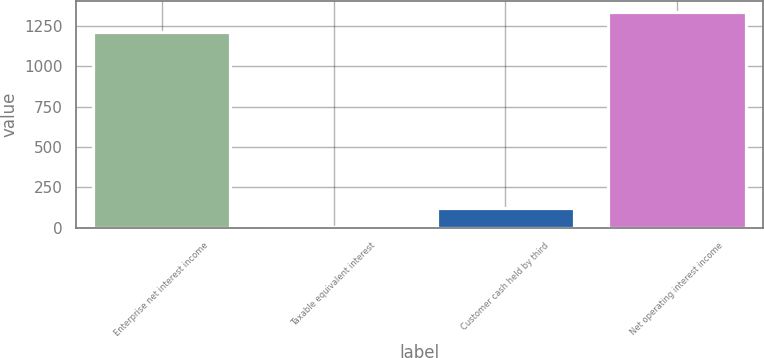Convert chart to OTSL. <chart><loc_0><loc_0><loc_500><loc_500><bar_chart><fcel>Enterprise net interest income<fcel>Taxable equivalent interest<fcel>Customer cash held by third<fcel>Net operating interest income<nl><fcel>1213.9<fcel>1.2<fcel>123.08<fcel>1335.78<nl></chart> 